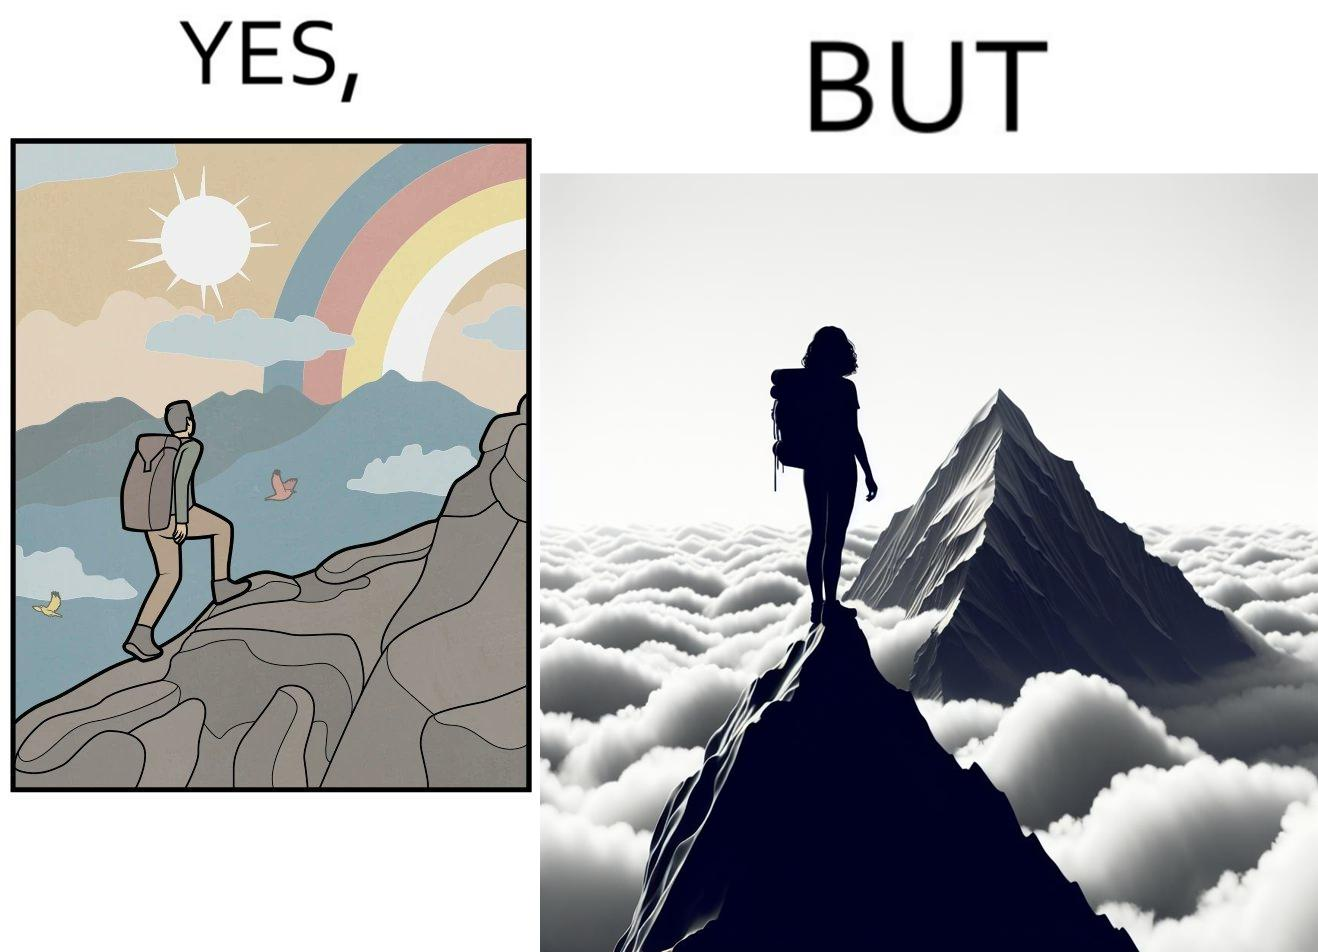Is this image satirical or non-satirical? Yes, this image is satirical. 